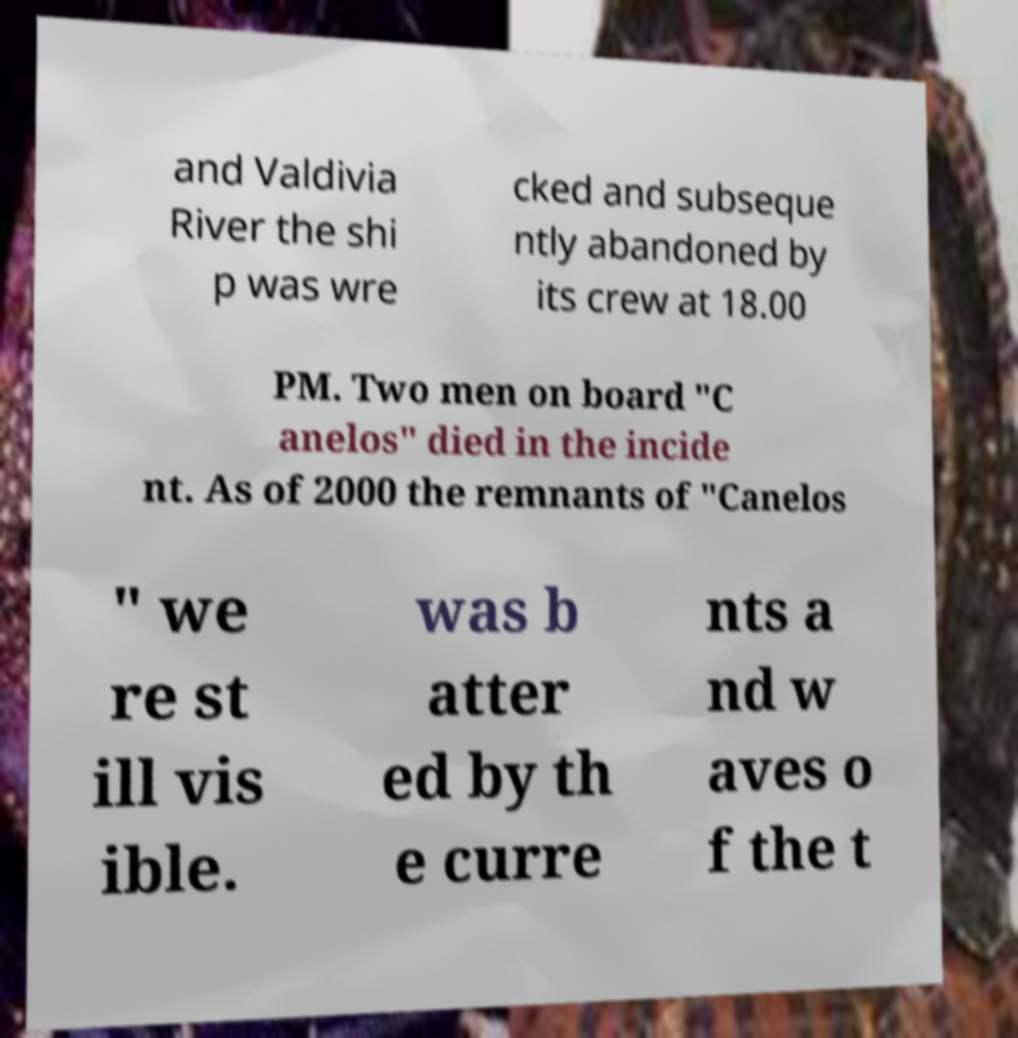For documentation purposes, I need the text within this image transcribed. Could you provide that? and Valdivia River the shi p was wre cked and subseque ntly abandoned by its crew at 18.00 PM. Two men on board "C anelos" died in the incide nt. As of 2000 the remnants of "Canelos " we re st ill vis ible. was b atter ed by th e curre nts a nd w aves o f the t 